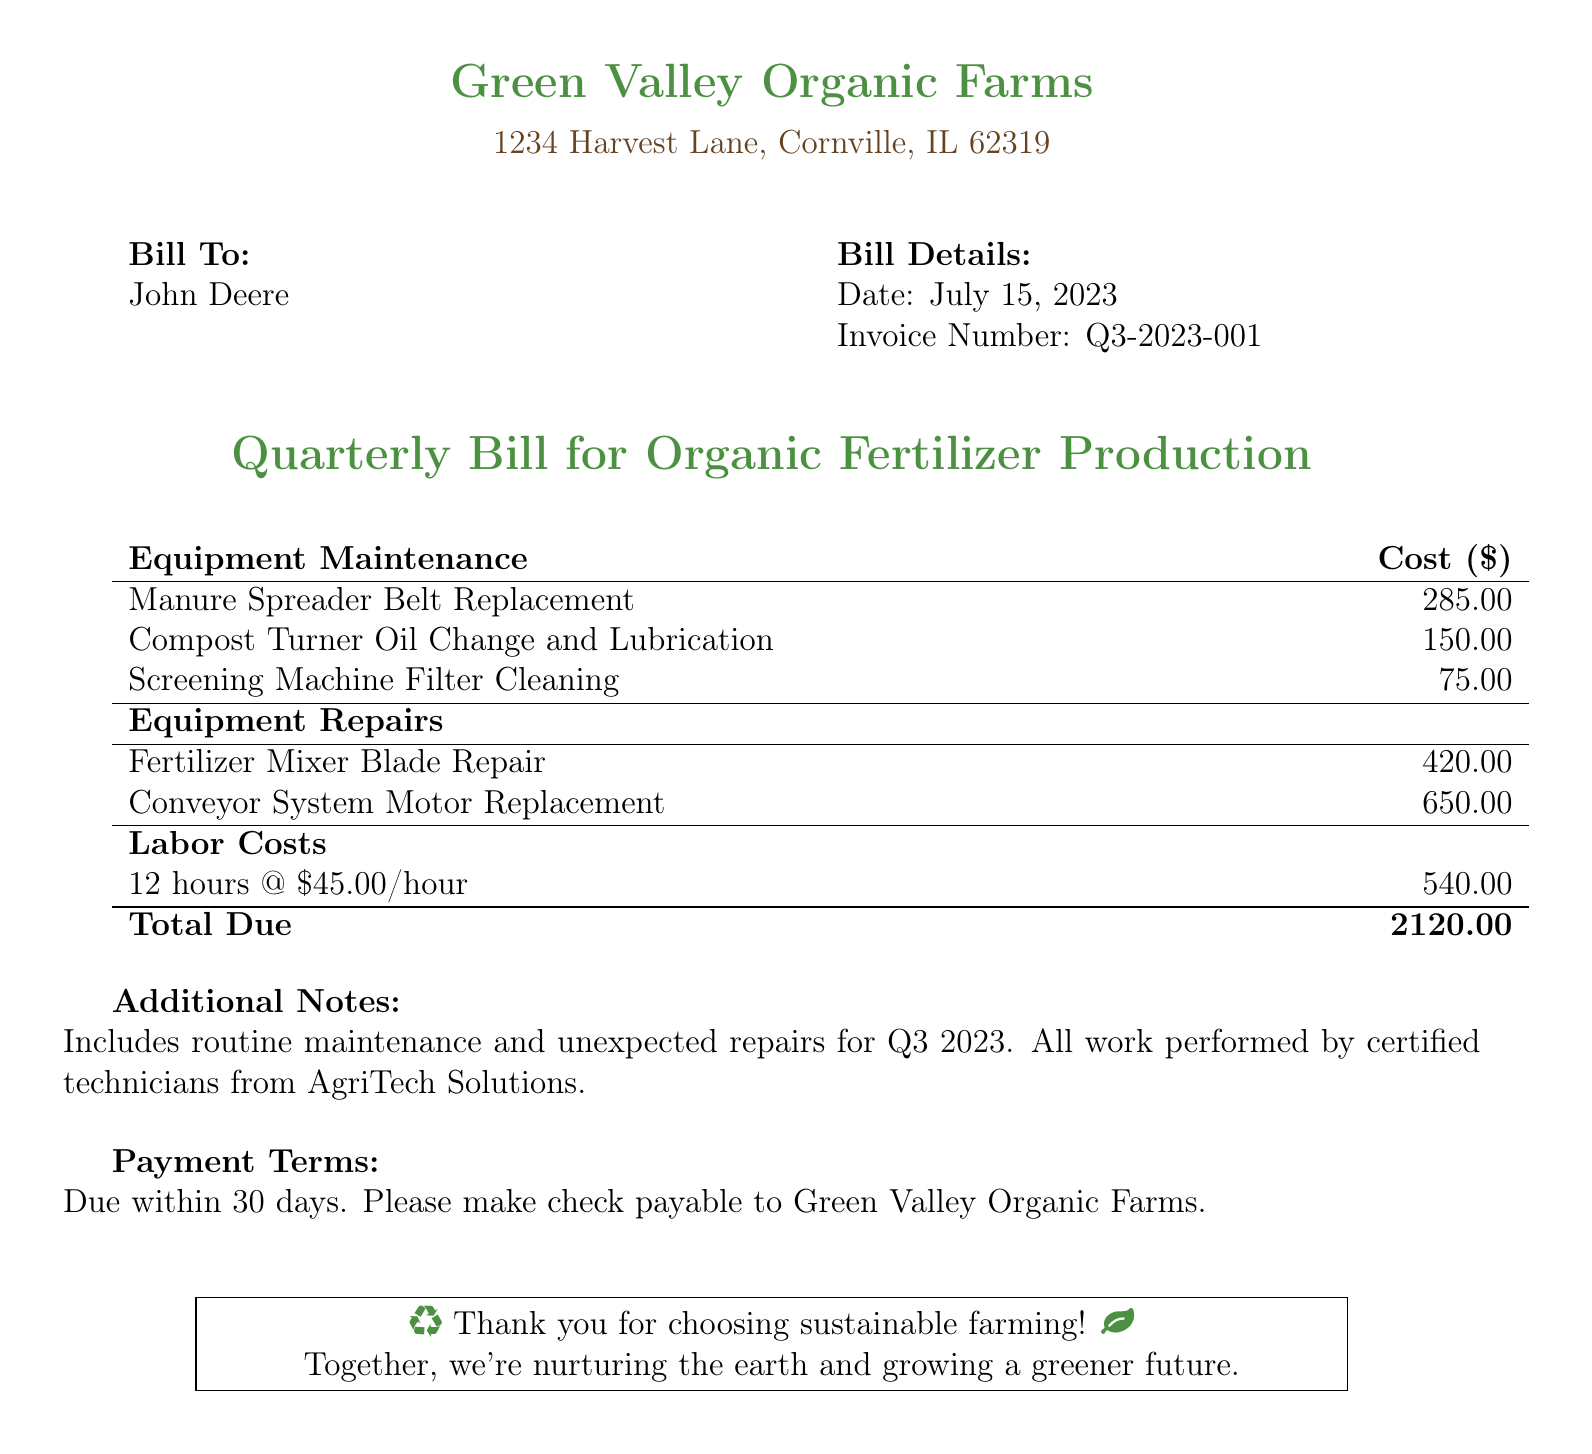What is the date of the bill? The date of the bill is listed under Bill Details, which states July 15, 2023.
Answer: July 15, 2023 What is the invoice number? The invoice number is provided in the Bill Details section as Q3-2023-001.
Answer: Q3-2023-001 How much was charged for the Fertilizer Mixer Blade Repair? The cost for the Fertilizer Mixer Blade Repair can be found under Equipment Repairs, which shows 420.00.
Answer: 420.00 What are the total labor costs? The total labor costs are specified in the Labor Costs section as 540.00 for 12 hours of work at 45.00 per hour.
Answer: 540.00 What is the total amount due? The total amount due is summarized at the bottom of the bill, amounting to 2120.00.
Answer: 2120.00 Who performed the maintenance and repairs? The additional notes mention that the work was performed by certified technicians from AgriTech Solutions.
Answer: AgriTech Solutions What payment term is specified in the document? The payment terms are clearly stated, requiring payment to be made within 30 days.
Answer: 30 days How many hours of labor were billed? The labor costs section indicates that 12 hours were billed for the maintenance and repairs.
Answer: 12 hours What is the cost of the Conveyor System Motor Replacement? The cost for the Conveyor System Motor Replacement is found in Equipment Repairs and is 650.00.
Answer: 650.00 